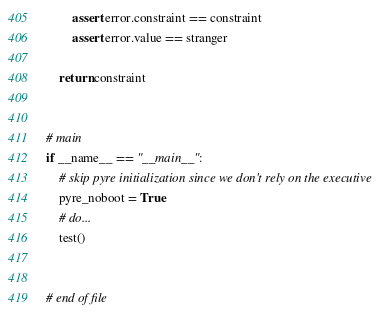Convert code to text. <code><loc_0><loc_0><loc_500><loc_500><_Python_>        assert error.constraint == constraint
        assert error.value == stranger

    return constraint


# main
if __name__ == "__main__":
    # skip pyre initialization since we don't rely on the executive
    pyre_noboot = True
    # do...
    test()


# end of file
</code> 